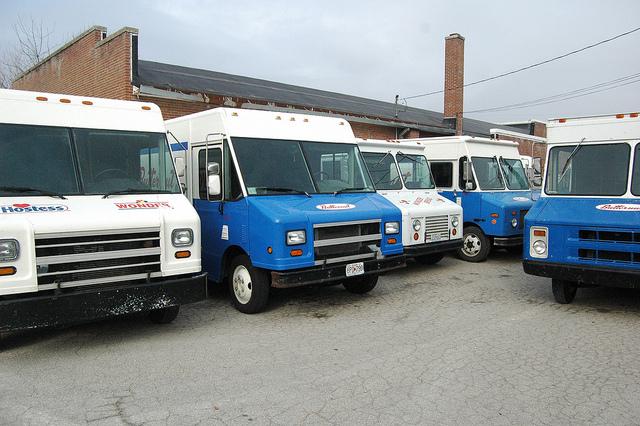What color are the trucks?
Concise answer only. Blue and white. Which truck has car plate?
Be succinct. 2nd from left. What is written on the trucks?
Write a very short answer. Hostess. 